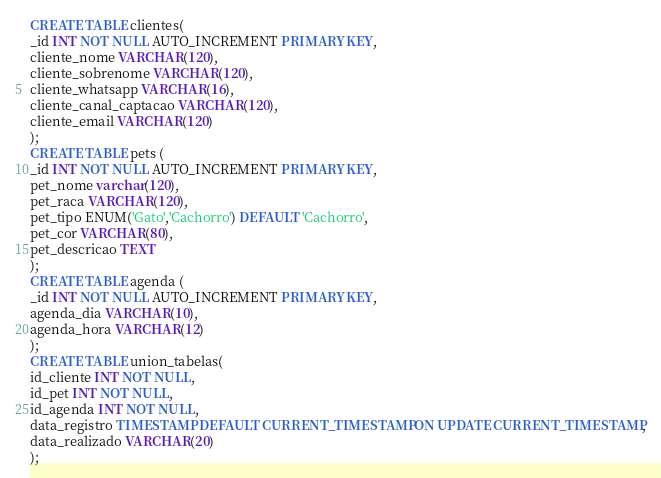<code> <loc_0><loc_0><loc_500><loc_500><_SQL_>CREATE TABLE clientes(
_id INT NOT NULL AUTO_INCREMENT PRIMARY KEY,
cliente_nome VARCHAR(120),
cliente_sobrenome VARCHAR(120),
cliente_whatsapp VARCHAR(16),
cliente_canal_captacao VARCHAR(120),
cliente_email VARCHAR(120)
);
CREATE TABLE pets (
_id INT NOT NULL AUTO_INCREMENT PRIMARY KEY,
pet_nome varchar(120),
pet_raca VARCHAR(120),
pet_tipo ENUM('Gato','Cachorro') DEFAULT 'Cachorro',
pet_cor VARCHAR(80),
pet_descricao TEXT
);
CREATE TABLE agenda (
_id INT NOT NULL AUTO_INCREMENT PRIMARY KEY,
agenda_dia VARCHAR(10),
agenda_hora VARCHAR(12)
);
CREATE TABLE union_tabelas(
id_cliente INT NOT NULL,
id_pet INT NOT NULL,
id_agenda INT NOT NULL,
data_registro TIMESTAMP DEFAULT CURRENT_TIMESTAMP ON UPDATE CURRENT_TIMESTAMP,
data_realizado VARCHAR(20)
);</code> 